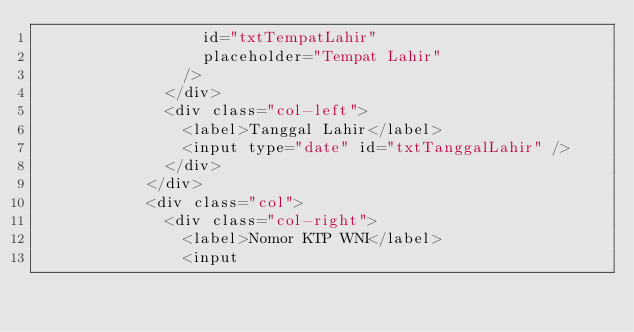<code> <loc_0><loc_0><loc_500><loc_500><_HTML_>                  id="txtTempatLahir"
                  placeholder="Tempat Lahir"
                />
              </div>
              <div class="col-left">
                <label>Tanggal Lahir</label>
                <input type="date" id="txtTanggalLahir" />
              </div>
            </div>
            <div class="col">
              <div class="col-right">
                <label>Nomor KTP WNI</label>
                <input</code> 